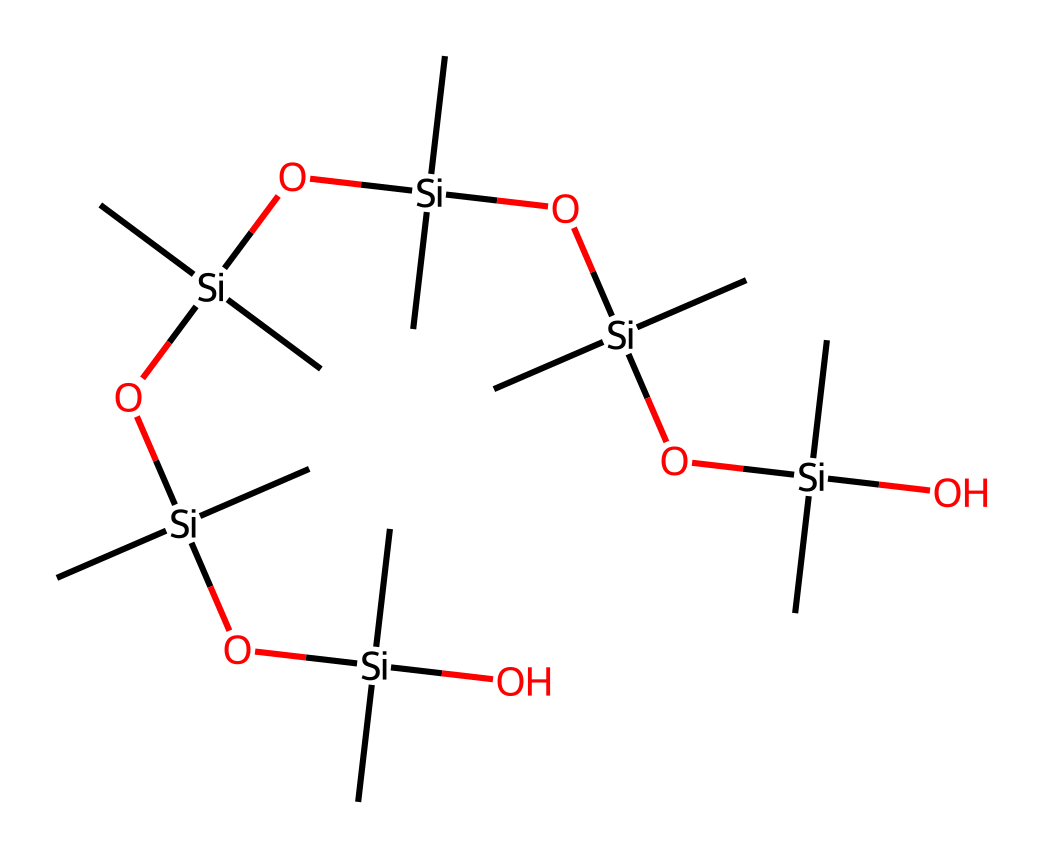What is the main element in the structure of dimethicone? The main element in this chemical structure is silicon, which is present as multiple silicon atoms (Si) that forms the backbone of the molecule.
Answer: silicon How many silicon atoms are present in the molecule? By counting the occurrences of the silicon (Si) symbol in the SMILES representation, you can identify that there are six silicon atoms in total.
Answer: six What type of bonding is primarily found in dimethicone? Dimethicone primarily exhibits siloxane bonding, characterized by Si-O bonds forming a polymeric chain structure.
Answer: siloxane What functional groups are present in dimethicone? The molecule contains hydroxyl (-OH) groups and siloxane (Si-O) linkages, indicating the presence of both functional groups.
Answer: hydroxyl and siloxane How many carbon atoms are present in the structure? By observing the carbon (C) symbols in the SMILES representation, one can count that there are twelve carbon atoms in total.
Answer: twelve What is a common use of dimethicone in cosmetics? Dimethicone is widely used as a silicone-based emollient and skin-conditioning agent, providing a smooth, silky feel.
Answer: emollient Why is dimethicone often preferred in formulations? Dimethicone's low surface tension and spreadability make it ideal for enhancing texture and providing a non-greasy finish in cosmetic products.
Answer: spreadability and texture 